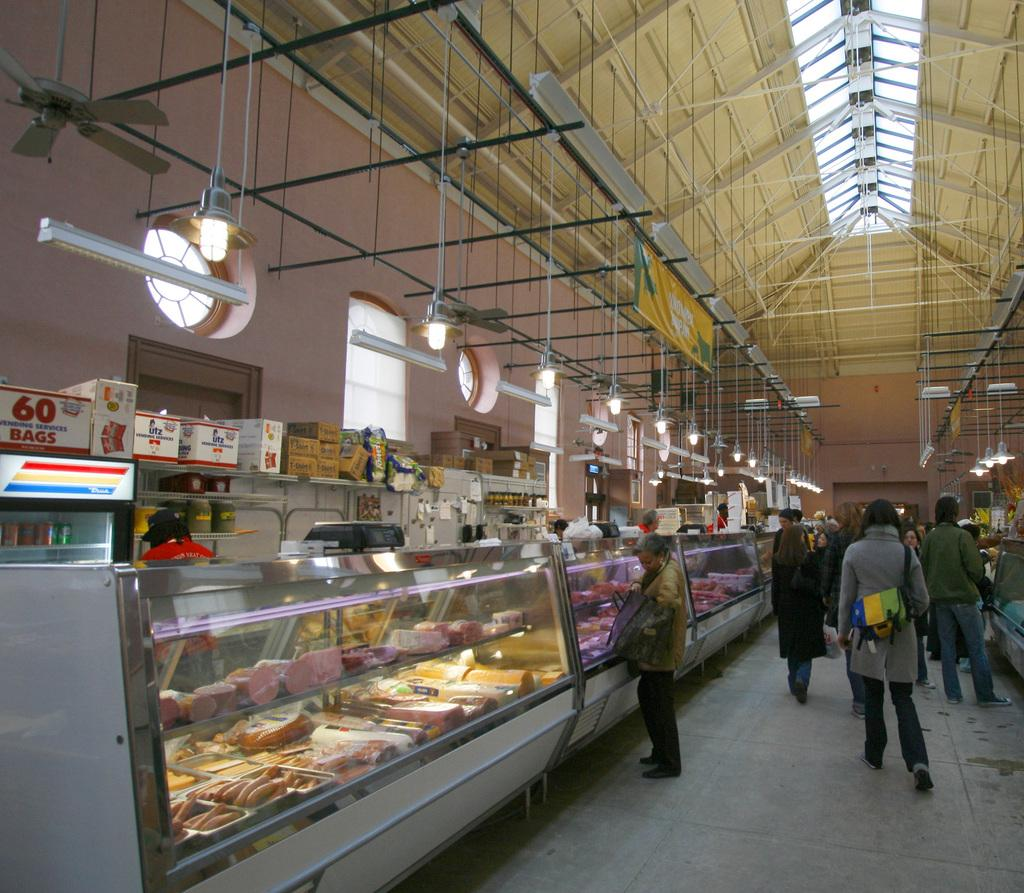<image>
Provide a brief description of the given image. Looking down a fresh meat market with a box of 60 bags on a shelf 